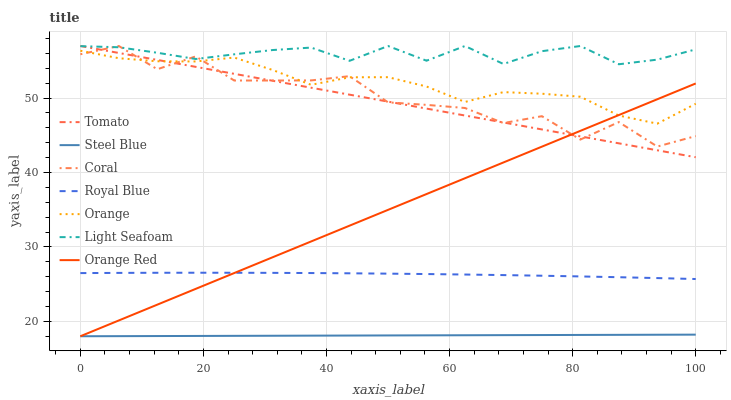Does Steel Blue have the minimum area under the curve?
Answer yes or no. Yes. Does Light Seafoam have the maximum area under the curve?
Answer yes or no. Yes. Does Coral have the minimum area under the curve?
Answer yes or no. No. Does Coral have the maximum area under the curve?
Answer yes or no. No. Is Steel Blue the smoothest?
Answer yes or no. Yes. Is Coral the roughest?
Answer yes or no. Yes. Is Coral the smoothest?
Answer yes or no. No. Is Steel Blue the roughest?
Answer yes or no. No. Does Steel Blue have the lowest value?
Answer yes or no. Yes. Does Coral have the lowest value?
Answer yes or no. No. Does Light Seafoam have the highest value?
Answer yes or no. Yes. Does Steel Blue have the highest value?
Answer yes or no. No. Is Steel Blue less than Light Seafoam?
Answer yes or no. Yes. Is Orange greater than Royal Blue?
Answer yes or no. Yes. Does Orange intersect Tomato?
Answer yes or no. Yes. Is Orange less than Tomato?
Answer yes or no. No. Is Orange greater than Tomato?
Answer yes or no. No. Does Steel Blue intersect Light Seafoam?
Answer yes or no. No. 